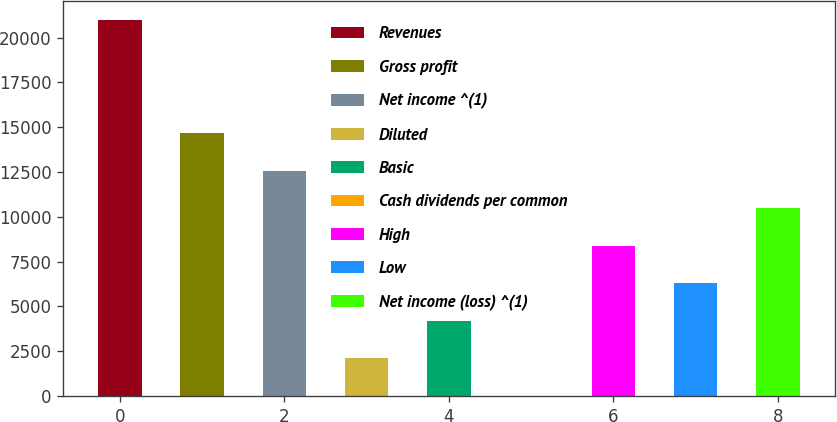Convert chart to OTSL. <chart><loc_0><loc_0><loc_500><loc_500><bar_chart><fcel>Revenues<fcel>Gross profit<fcel>Net income ^(1)<fcel>Diluted<fcel>Basic<fcel>Cash dividends per common<fcel>High<fcel>Low<fcel>Net income (loss) ^(1)<nl><fcel>20968<fcel>14677.6<fcel>12580.8<fcel>2096.85<fcel>4193.64<fcel>0.06<fcel>8387.22<fcel>6290.43<fcel>10484<nl></chart> 